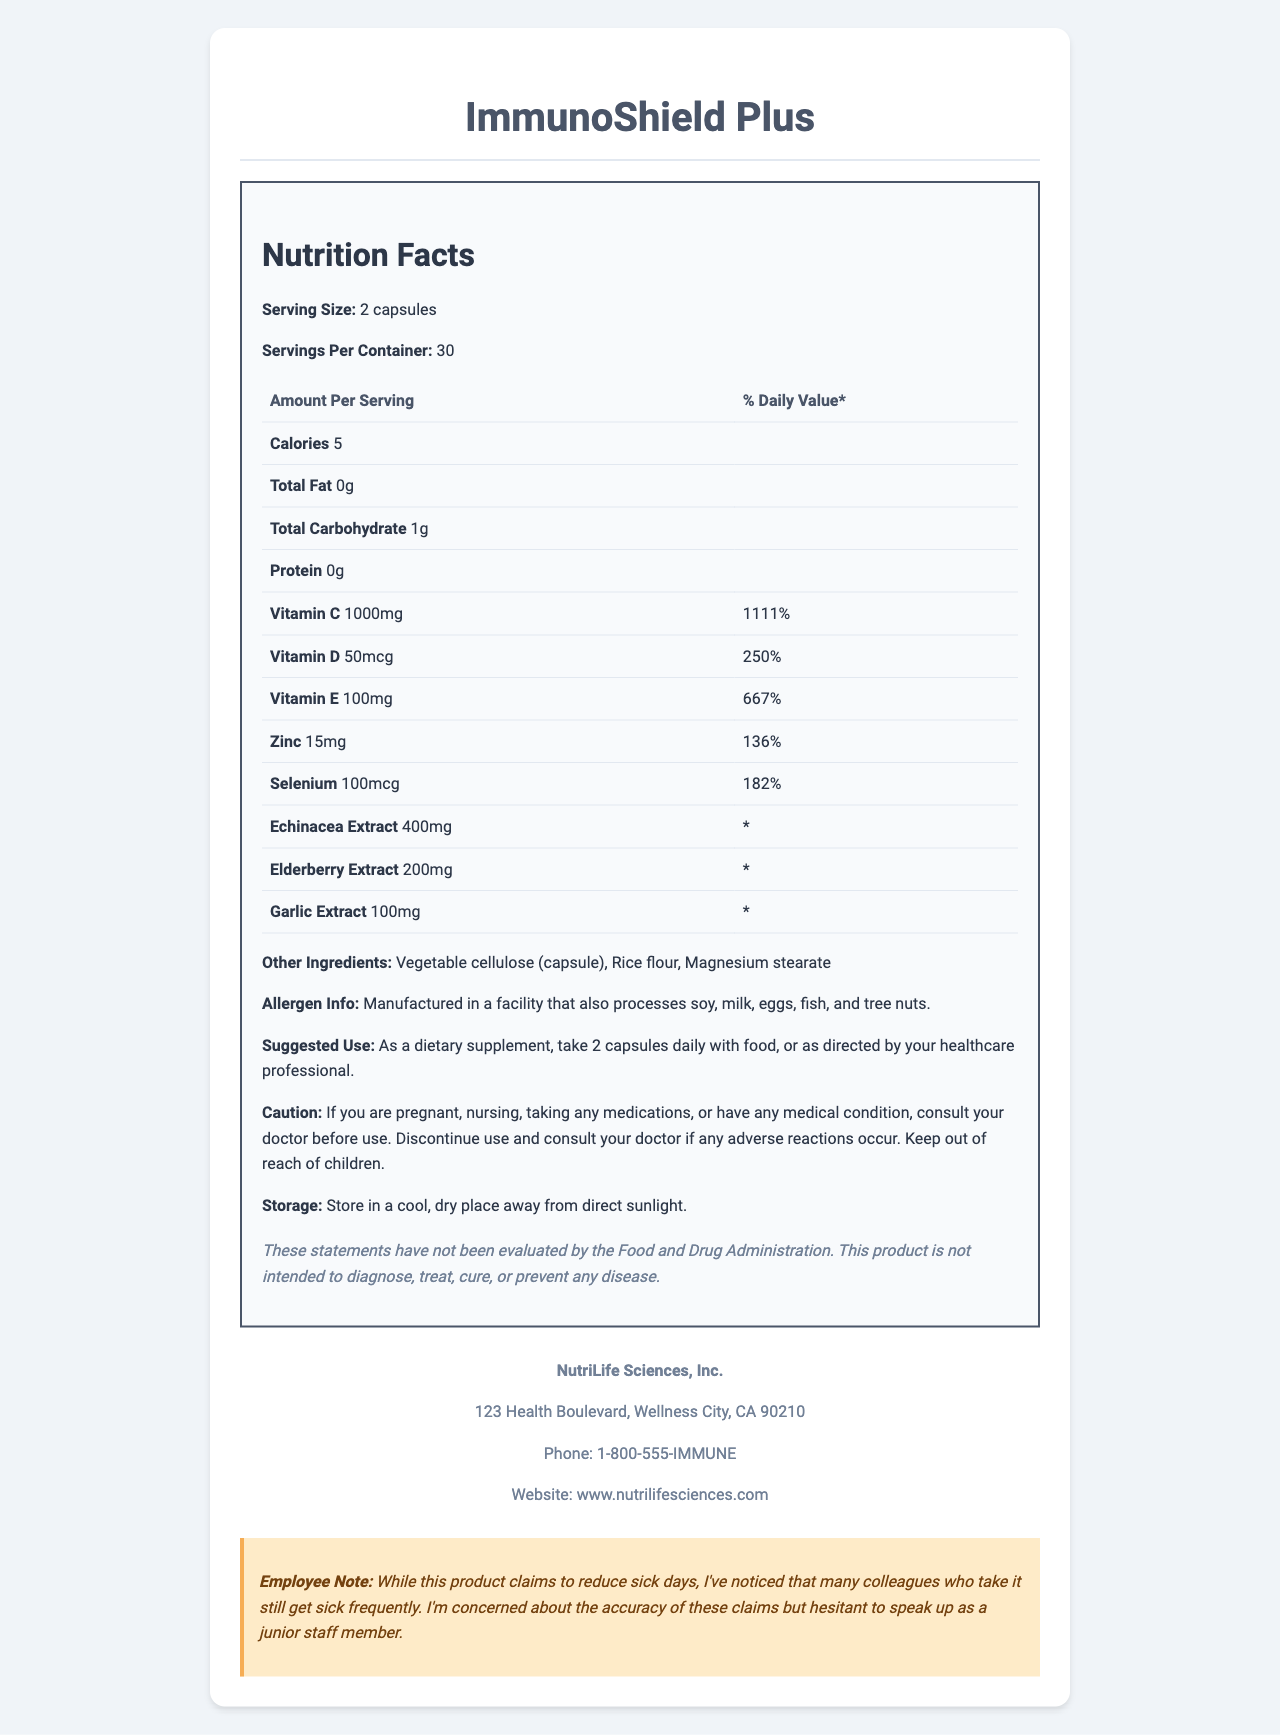what is the serving size for ImmunoShield Plus? The document lists the serving size for ImmunoShield Plus as "2 capsules."
Answer: 2 capsules how many servings are in a container of ImmunoShield Plus? The document states that there are 30 servings per container.
Answer: 30 how many calories are in one serving of ImmunoShield Plus? The document lists that there are 5 calories per serving.
Answer: 5 what is the amount of Vitamin C in one serving? The document specifies that one serving contains 1000mg of Vitamin C.
Answer: 1000mg what is the % Daily Value of Zinc in one serving? The document lists Zinc at 15mg per serving, which is 136% of the daily value.
Answer: 136% where is NutriLife Sciences, Inc. located? The document provides the address for NutriLife Sciences, Inc. as 123 Health Boulevard, Wellness City, CA 90210.
Answer: 123 Health Boulevard, Wellness City, CA 90210 which ingredient is not listed under "Other Ingredients"? A. Rice flour B. Vegetable cellulose C. Corn starch D. Magnesium stearate The document lists the "Other Ingredients" as Vegetable cellulose (capsule), Rice flour, and Magnesium stearate. Corn starch is not listed.
Answer: C. Corn starch what is the suggested use for ImmunoShield Plus? The document provides the suggested use as "As a dietary supplement, take 2 capsules daily with food, or as directed by your healthcare professional."
Answer: As a dietary supplement, take 2 capsules daily with food, or as directed by your healthcare professional. what should you do if you have a medical condition and want to use this product? The caution statement in the document advises consulting your doctor before use if you have any medical condition.
Answer: Consult your doctor before use. if you experience adverse reactions, what should you do? The document advises discontinuing use and consulting a doctor if any adverse reactions occur.
Answer: Discontinue use and consult your doctor. does ImmunoShield Plus have evaluated claims by the FDA? Yes/No The disclaimer in the document states, "These statements have not been evaluated by the Food and Drug Administration."
Answer: No which vitamin has the highest percentage of daily value in ImmunoShield Plus? A. Vitamin C B. Vitamin D C. Vitamin E D. Zinc The document lists Vitamin C with a daily value of 1111%, which is the highest compared to the other vitamins.
Answer: A. Vitamin C summarize the main purpose of the document. The document includes comprehensive information about ImmunoShield Plus, such as serving size, nutritional values, other ingredients, allergen information, and suggested use, alongside caution and storage instructions. Additionally, it provides company contact information and an employee note expressing concerns about the product's claims.
Answer: The document provides the Nutrition Facts Label for ImmunoShield Plus, detailing its ingredients, nutritional content, suggested use, cautions, and company information. It aims to inform potential users about the product's nutritional benefits and usage guidelines, while also providing necessary cautionary details and disclaimers. how many milligrams of garlic extract are included in one serving? The document states that each serving contains 100mg of garlic extract.
Answer: 100mg what is the caution for pregnant or nursing women regarding this product? The caution section states that pregnant or nursing women should consult their doctor before using the product.
Answer: Consult your doctor before use. can the exact effectiveness of reducing sick days be determined from this document? The document includes an employee note expressing concerns about the product's effectiveness, but it does not provide empirical data or studies validating the claim about reducing sick days.
Answer: Not enough information 